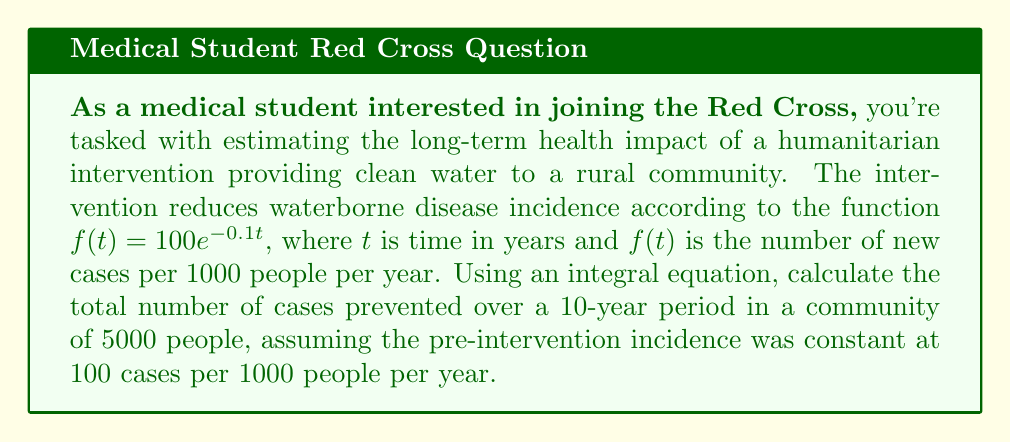Show me your answer to this math problem. To solve this problem, we'll follow these steps:

1) First, let's define the function for cases prevented per 1000 people:
   $g(t) = 100 - f(t) = 100 - 100e^{-0.1t} = 100(1 - e^{-0.1t})$

2) To find the total cases prevented over 10 years, we need to integrate this function from 0 to 10:
   $$\int_0^{10} g(t) dt = \int_0^{10} 100(1 - e^{-0.1t}) dt$$

3) Let's solve this integral:
   $$\int_0^{10} 100(1 - e^{-0.1t}) dt = 100 \left[t + 10e^{-0.1t}\right]_0^{10}$$
   $$= 100 \left[(10 + 10e^{-1}) - (0 + 10)\right]$$
   $$= 100 (10 + 3.679 - 10) = 367.9$$

4) This result is per 1000 people. For a community of 5000 people, we multiply by 5:
   $367.9 * 5 = 1839.5$

Therefore, the intervention prevents approximately 1840 cases over 10 years in a community of 5000 people.
Answer: 1840 cases 